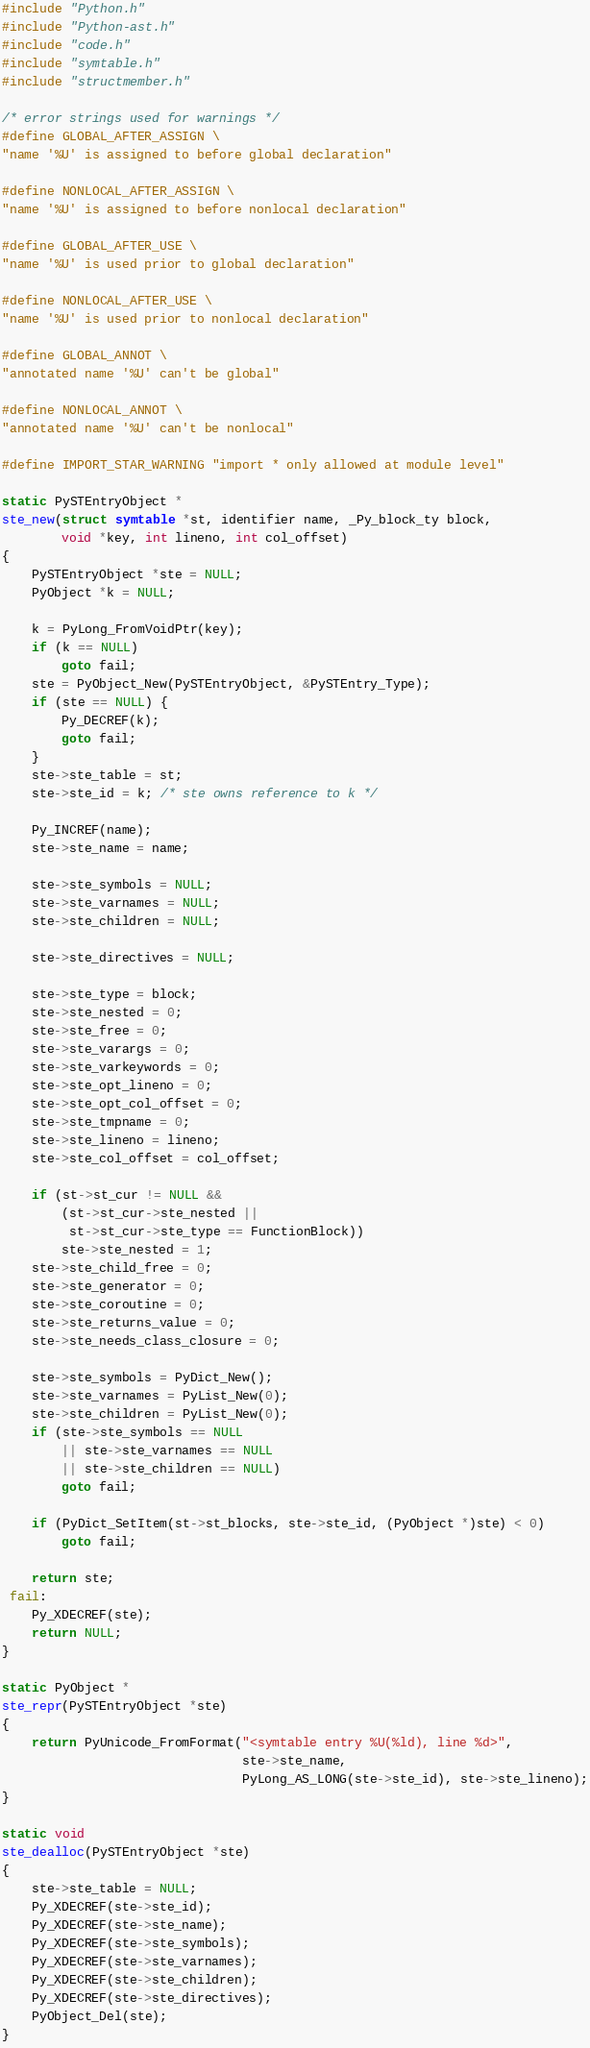Convert code to text. <code><loc_0><loc_0><loc_500><loc_500><_C_>#include "Python.h"
#include "Python-ast.h"
#include "code.h"
#include "symtable.h"
#include "structmember.h"

/* error strings used for warnings */
#define GLOBAL_AFTER_ASSIGN \
"name '%U' is assigned to before global declaration"

#define NONLOCAL_AFTER_ASSIGN \
"name '%U' is assigned to before nonlocal declaration"

#define GLOBAL_AFTER_USE \
"name '%U' is used prior to global declaration"

#define NONLOCAL_AFTER_USE \
"name '%U' is used prior to nonlocal declaration"

#define GLOBAL_ANNOT \
"annotated name '%U' can't be global"

#define NONLOCAL_ANNOT \
"annotated name '%U' can't be nonlocal"

#define IMPORT_STAR_WARNING "import * only allowed at module level"

static PySTEntryObject *
ste_new(struct symtable *st, identifier name, _Py_block_ty block,
        void *key, int lineno, int col_offset)
{
    PySTEntryObject *ste = NULL;
    PyObject *k = NULL;

    k = PyLong_FromVoidPtr(key);
    if (k == NULL)
        goto fail;
    ste = PyObject_New(PySTEntryObject, &PySTEntry_Type);
    if (ste == NULL) {
        Py_DECREF(k);
        goto fail;
    }
    ste->ste_table = st;
    ste->ste_id = k; /* ste owns reference to k */

    Py_INCREF(name);
    ste->ste_name = name;

    ste->ste_symbols = NULL;
    ste->ste_varnames = NULL;
    ste->ste_children = NULL;

    ste->ste_directives = NULL;

    ste->ste_type = block;
    ste->ste_nested = 0;
    ste->ste_free = 0;
    ste->ste_varargs = 0;
    ste->ste_varkeywords = 0;
    ste->ste_opt_lineno = 0;
    ste->ste_opt_col_offset = 0;
    ste->ste_tmpname = 0;
    ste->ste_lineno = lineno;
    ste->ste_col_offset = col_offset;

    if (st->st_cur != NULL &&
        (st->st_cur->ste_nested ||
         st->st_cur->ste_type == FunctionBlock))
        ste->ste_nested = 1;
    ste->ste_child_free = 0;
    ste->ste_generator = 0;
    ste->ste_coroutine = 0;
    ste->ste_returns_value = 0;
    ste->ste_needs_class_closure = 0;

    ste->ste_symbols = PyDict_New();
    ste->ste_varnames = PyList_New(0);
    ste->ste_children = PyList_New(0);
    if (ste->ste_symbols == NULL
        || ste->ste_varnames == NULL
        || ste->ste_children == NULL)
        goto fail;

    if (PyDict_SetItem(st->st_blocks, ste->ste_id, (PyObject *)ste) < 0)
        goto fail;

    return ste;
 fail:
    Py_XDECREF(ste);
    return NULL;
}

static PyObject *
ste_repr(PySTEntryObject *ste)
{
    return PyUnicode_FromFormat("<symtable entry %U(%ld), line %d>",
                                ste->ste_name,
                                PyLong_AS_LONG(ste->ste_id), ste->ste_lineno);
}

static void
ste_dealloc(PySTEntryObject *ste)
{
    ste->ste_table = NULL;
    Py_XDECREF(ste->ste_id);
    Py_XDECREF(ste->ste_name);
    Py_XDECREF(ste->ste_symbols);
    Py_XDECREF(ste->ste_varnames);
    Py_XDECREF(ste->ste_children);
    Py_XDECREF(ste->ste_directives);
    PyObject_Del(ste);
}
</code> 